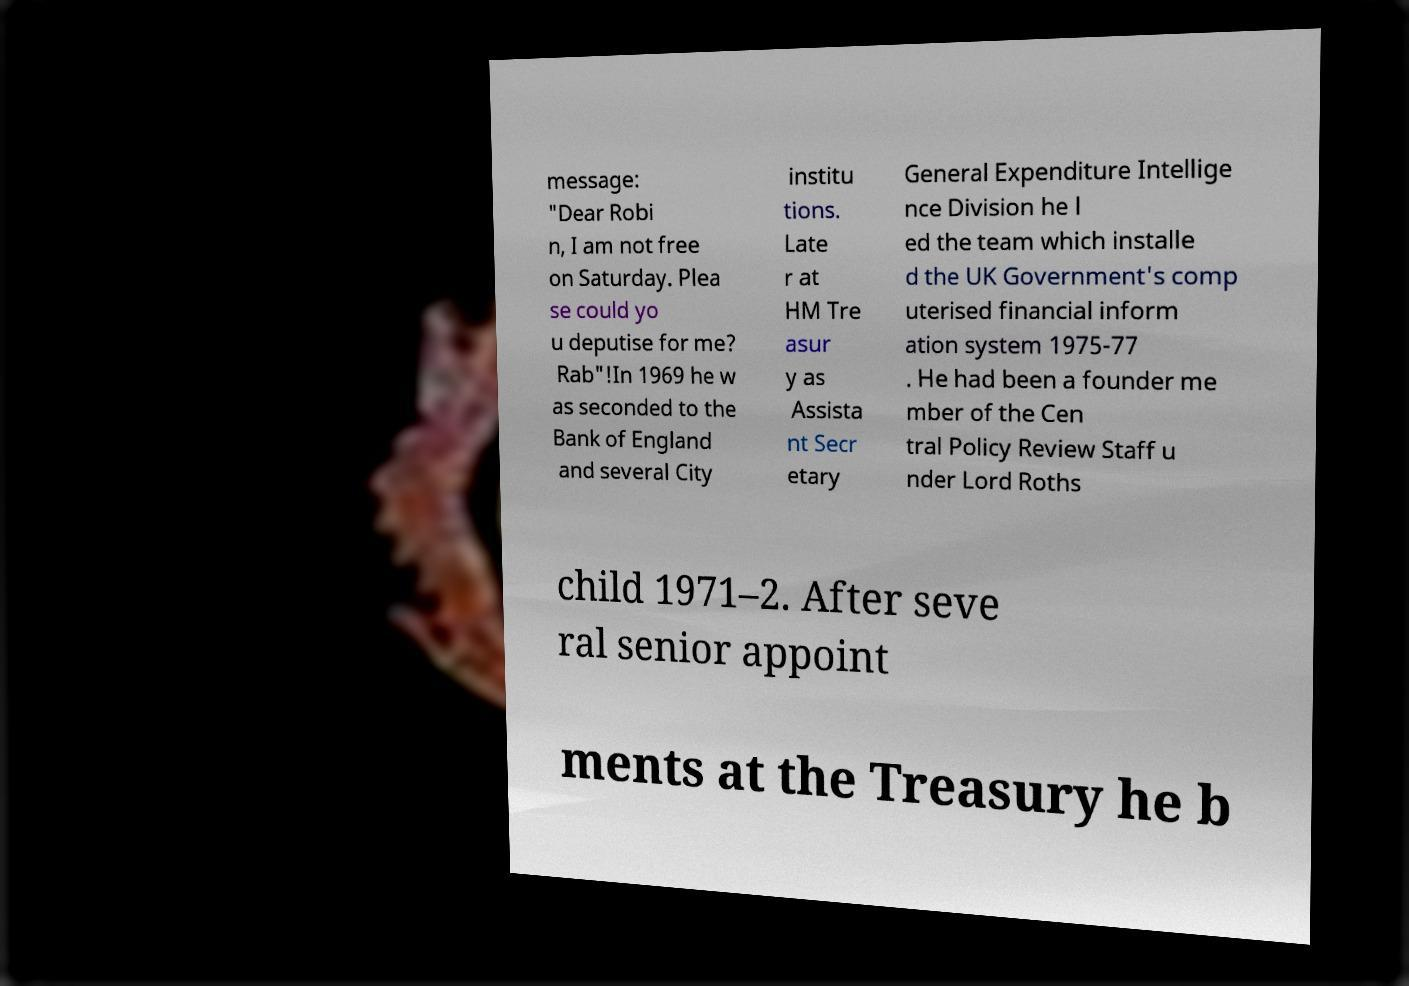Please identify and transcribe the text found in this image. message: "Dear Robi n, I am not free on Saturday. Plea se could yo u deputise for me? Rab"!In 1969 he w as seconded to the Bank of England and several City institu tions. Late r at HM Tre asur y as Assista nt Secr etary General Expenditure Intellige nce Division he l ed the team which installe d the UK Government's comp uterised financial inform ation system 1975-77 . He had been a founder me mber of the Cen tral Policy Review Staff u nder Lord Roths child 1971–2. After seve ral senior appoint ments at the Treasury he b 